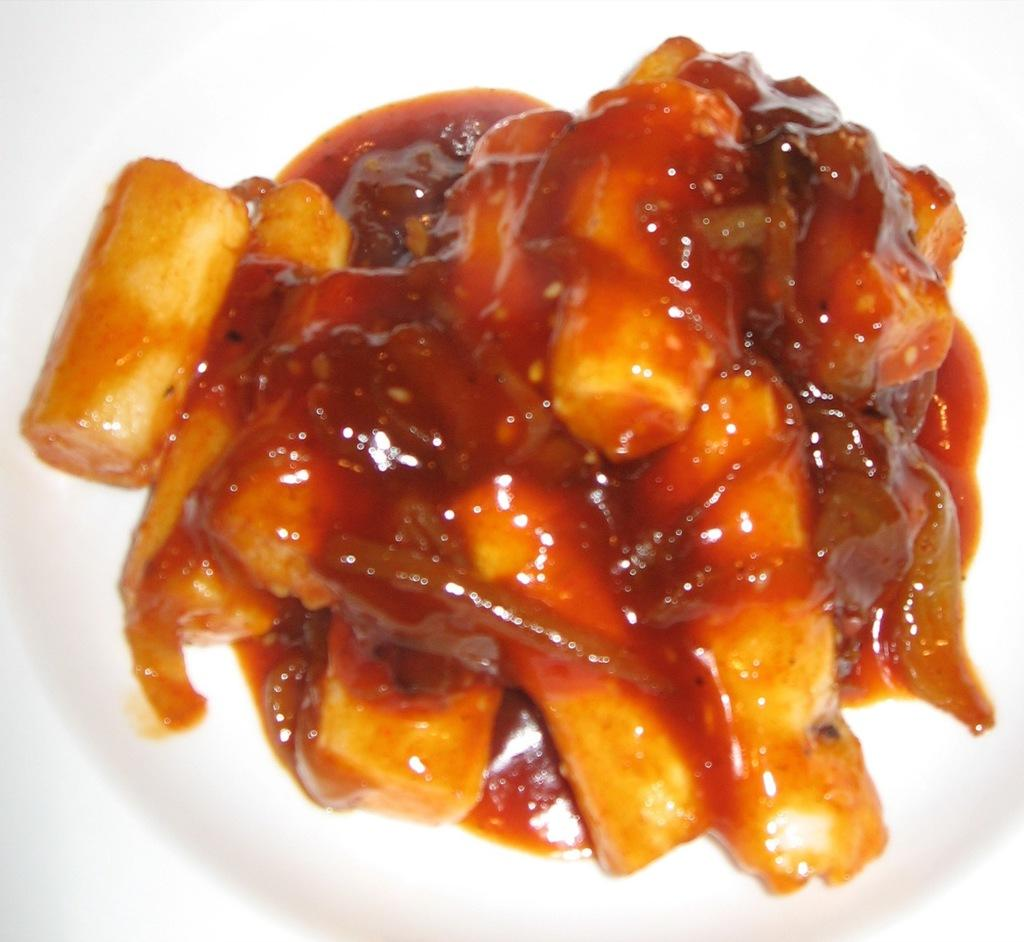What color is the plate that is visible in the image? The plate in the image is white. What is on top of the plate in the image? There is a dish on the plate. What type of advice is being given in the image? There is no advice present in the image; it only features a white color plate with a dish on it. 